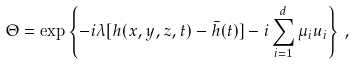Convert formula to latex. <formula><loc_0><loc_0><loc_500><loc_500>\Theta = \exp \left \{ - i \lambda [ h ( x , y , z , t ) - \bar { h } ( t ) ] - i \sum _ { i = 1 } ^ { d } \mu _ { i } u _ { i } \right \} \, ,</formula> 